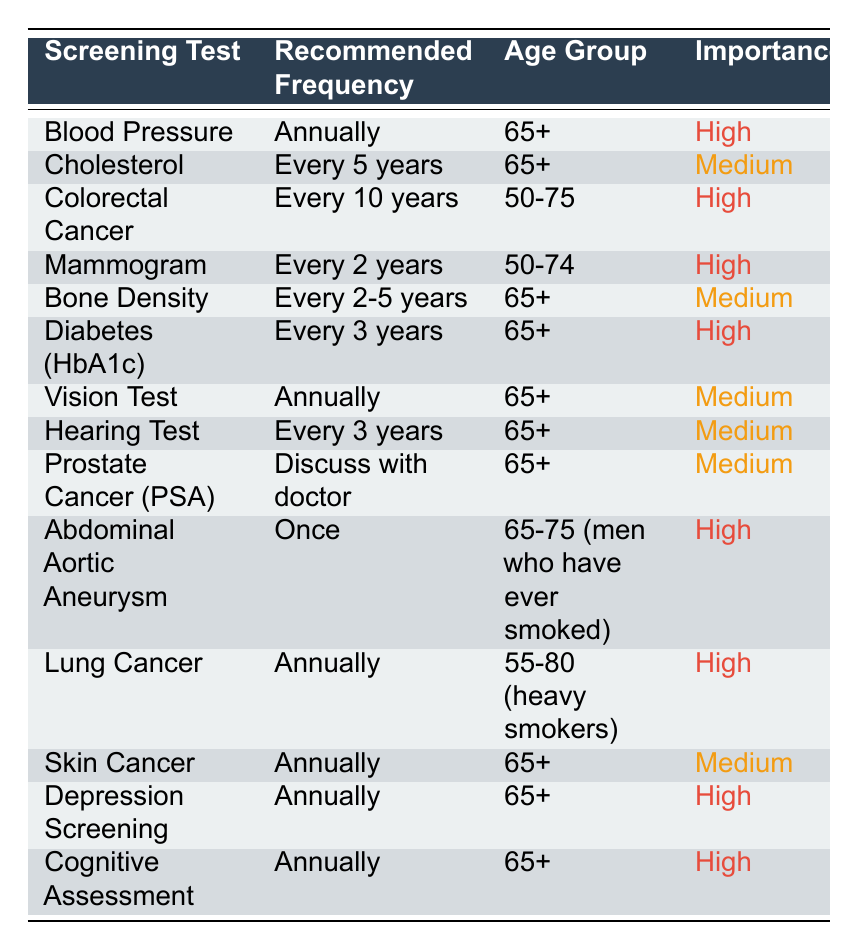What is the recommended frequency for Blood Pressure screening? The table indicates that Blood Pressure screening should be done "Annually" for seniors age 65 and older.
Answer: Annually How often should seniors aged 65 and older have a Vision Test? According to the table, seniors aged 65 and older should have a Vision Test "Annually."
Answer: Annually Is a Cholesterol screening recommended for seniors aged 65 and older? Yes, the table shows that Cholesterol screening is recommended "Every 5 years" for seniors in this age group.
Answer: Yes How many screening tests have a high importance rating for seniors aged 65 and older? To find this, we look for tests marked as "High" importance for the age group 65+. There are 6 tests: Blood Pressure, Diabetes (HbA1c), Abdominal Aortic Aneurysm, Lung Cancer, Depression Screening, and Cognitive Assessment.
Answer: 6 What is the frequency of screening for Prostate Cancer for seniors aged 65 and older? The table states that the frequency for Prostate Cancer screening is to "Discuss with doctor," providing no standard interval but indicating it is important to consult a healthcare provider for recommendations.
Answer: Discuss with doctor Which screening test has the longest interval and what is that interval? The longest interval mentioned in the table is for Colorectal Cancer screening, which is "Every 10 years."
Answer: Every 10 years Are seniors aged 55 to 80 who are heavy smokers recommended to have regular cancer screenings? Yes, the table shows that Lung Cancer screening is recommended "Annually" for seniors aged 55-80 who are heavy smokers.
Answer: Yes What is the combined frequency for Diabetes (HbA1c) and Hearing Test screenings for seniors aged 65 and older? Diabetes (HbA1c) is screened "Every 3 years," and the Hearing Test is screened "Every 3 years." To combine this, the frequency does not have a common interval but suggests that both should be considered at least every three years.
Answer: Every 3 years (individually) How often should women aged 50 to 74 have a Mammogram? Looking at the table, we see that Mammogram screening is recommended "Every 2 years" for women in the age group of 50-74.
Answer: Every 2 years Is Bone Density screening more frequently recommended than Cholesterol screening for seniors aged 65 and older? Cholesterol screening is recommended "Every 5 years" while Bone Density screening is recommended "Every 2-5 years," which suggests it could be done more frequently depending on the individual's circumstances. Thus, Bone Density could indeed be more often based on the upper limit of its frequency.
Answer: Yes 